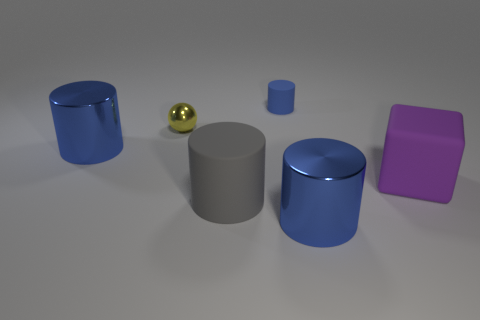Subtract all gray cylinders. How many cylinders are left? 3 Subtract all red spheres. How many blue cylinders are left? 3 Subtract all gray cylinders. How many cylinders are left? 3 Add 3 large gray rubber objects. How many objects exist? 9 Subtract all green cylinders. Subtract all green blocks. How many cylinders are left? 4 Subtract all cylinders. How many objects are left? 2 Add 3 purple metallic objects. How many purple metallic objects exist? 3 Subtract 0 blue cubes. How many objects are left? 6 Subtract all tiny metal things. Subtract all gray matte things. How many objects are left? 4 Add 1 blue matte cylinders. How many blue matte cylinders are left? 2 